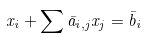<formula> <loc_0><loc_0><loc_500><loc_500>x _ { i } + \sum { \bar { a } } _ { i , j } x _ { j } = { \bar { b } } _ { i }</formula> 